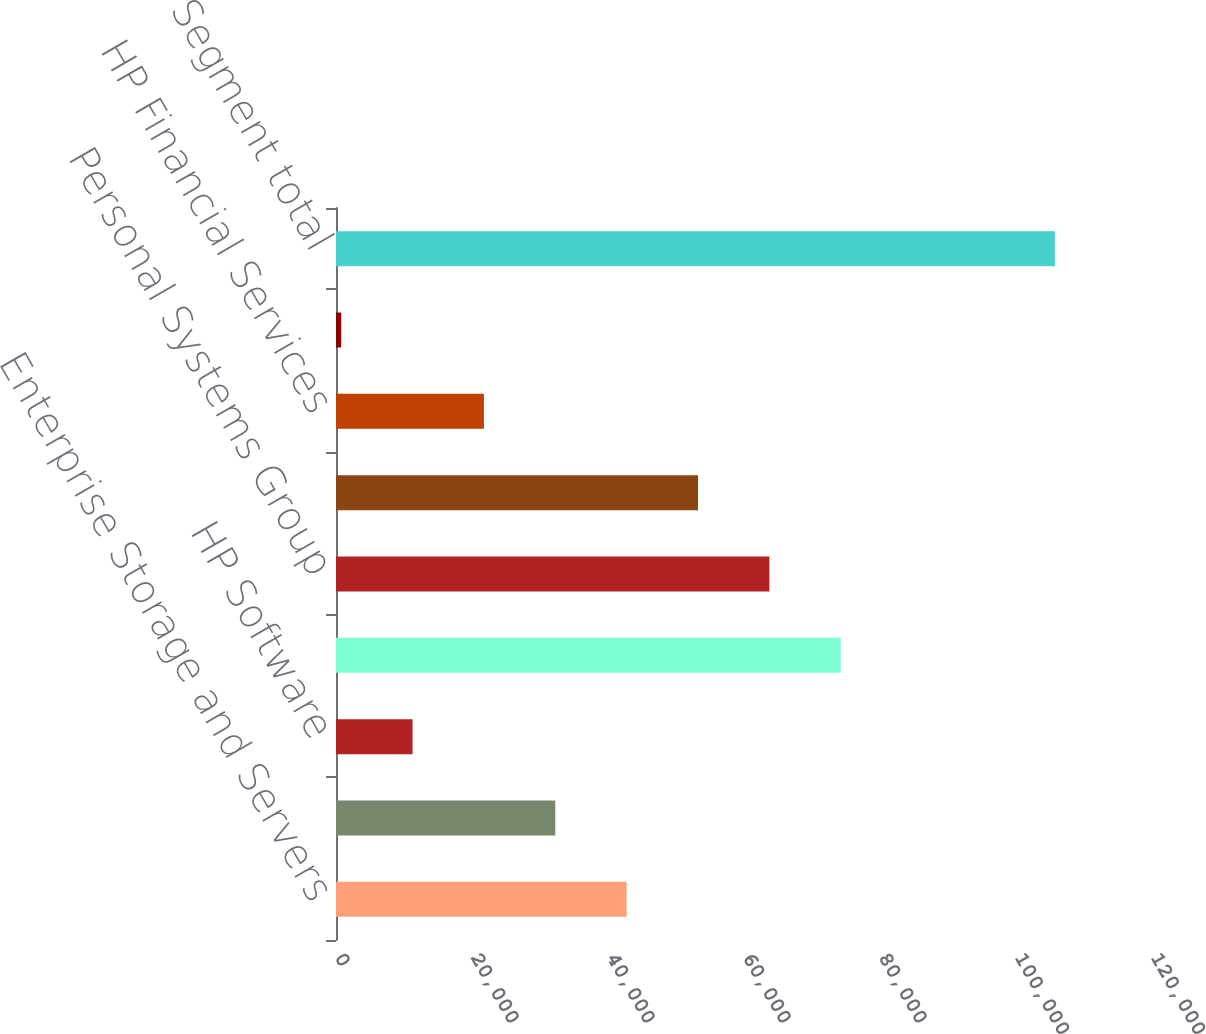Convert chart to OTSL. <chart><loc_0><loc_0><loc_500><loc_500><bar_chart><fcel>Enterprise Storage and Servers<fcel>HP Services<fcel>HP Software<fcel>Technology Solutions Group<fcel>Personal Systems Group<fcel>Imaging and Printing Group<fcel>HP Financial Services<fcel>Corporate Investments<fcel>Segment total<nl><fcel>42742<fcel>32247<fcel>11257<fcel>74227<fcel>63732<fcel>53237<fcel>21752<fcel>762<fcel>105712<nl></chart> 